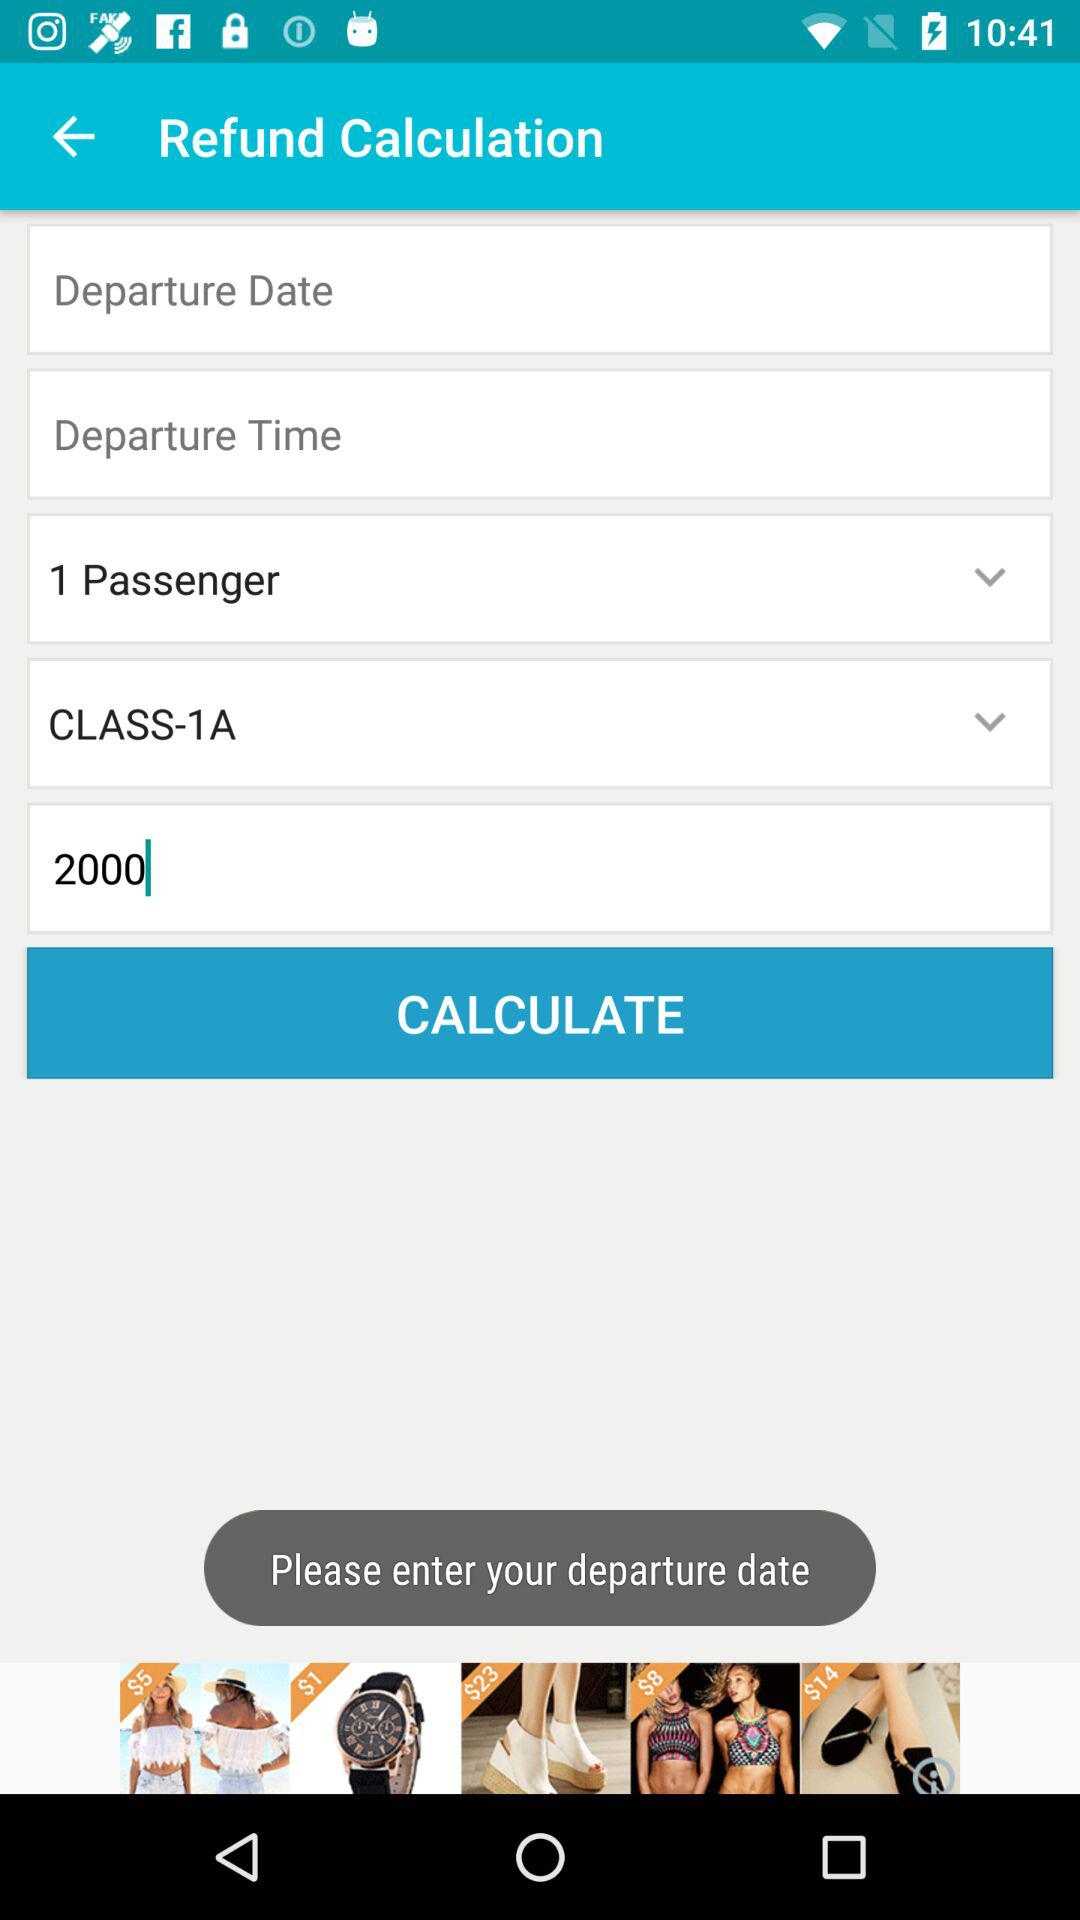How many passengers are in the refund calculation?
Answer the question using a single word or phrase. 1 